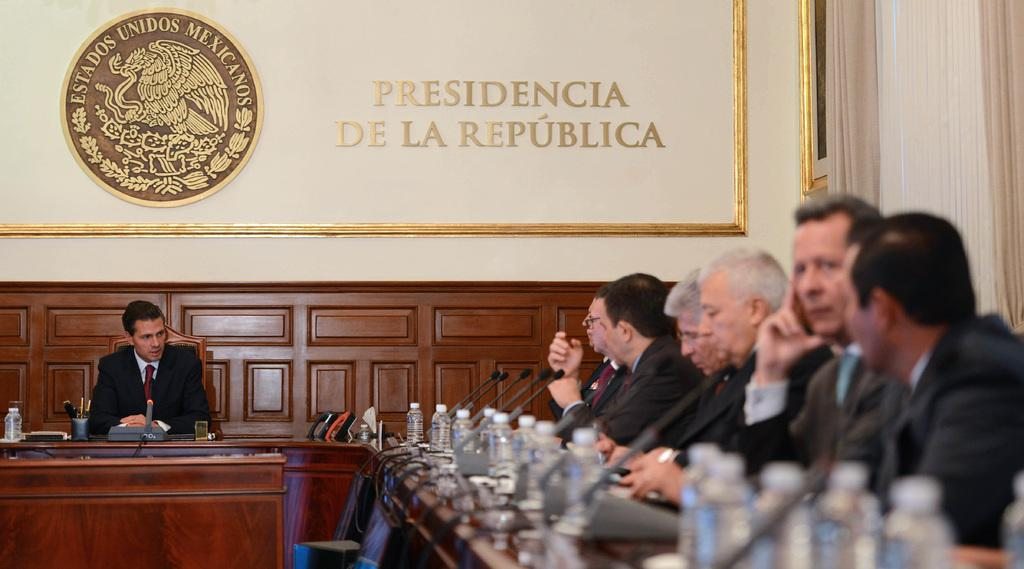What are the people in the image doing? The people in the image are sitting on chairs. What is in front of the people? There is a table in front of the people. What can be seen on the table? Water bottles and a microphone (mike) are present on the table. What type of copper material is used to make the bag in the image? There is no bag present in the image, and therefore no copper material can be observed. How many pages are visible in the image? There are no pages present in the image. 